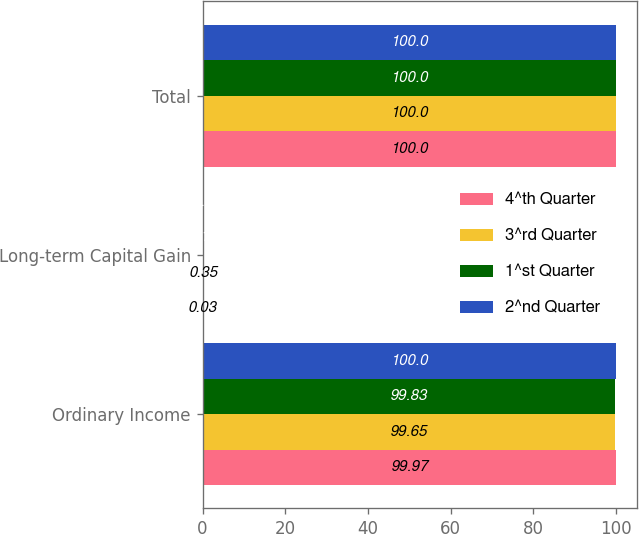<chart> <loc_0><loc_0><loc_500><loc_500><stacked_bar_chart><ecel><fcel>Ordinary Income<fcel>Long-term Capital Gain<fcel>Total<nl><fcel>4^th Quarter<fcel>99.97<fcel>0.03<fcel>100<nl><fcel>3^rd Quarter<fcel>99.65<fcel>0.35<fcel>100<nl><fcel>1^st Quarter<fcel>99.83<fcel>0.17<fcel>100<nl><fcel>2^nd Quarter<fcel>100<fcel>0<fcel>100<nl></chart> 